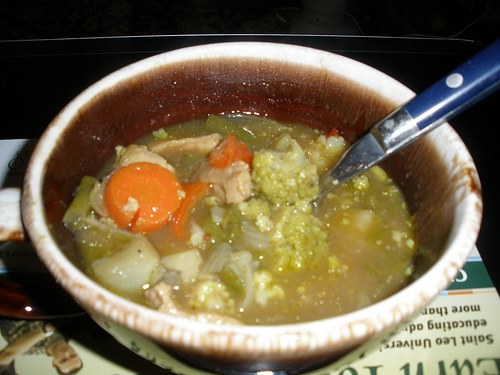Imagine you could add another vegetable to this soup. Which one would you add and why? If I could add another vegetable to this soup, I would choose to add some green peas. They would add a nice pop of color, a sweet flavor, and an extra layer of texture that complements the other vegetables well. 